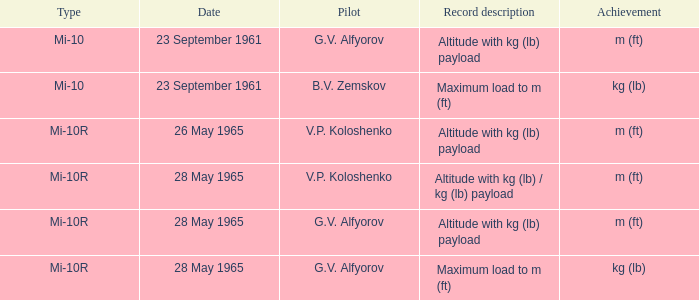Pilot of g.v. alfyorov, and a Record description of altitude with kg (lb) payload, and a Type of mi-10 involved what date? 23 September 1961. 